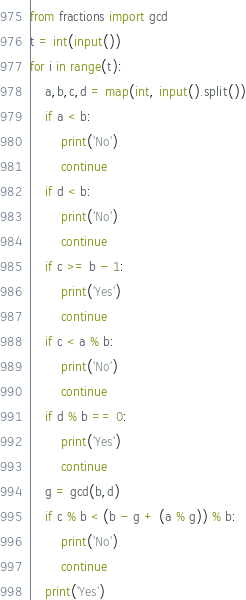<code> <loc_0><loc_0><loc_500><loc_500><_Python_>from fractions import gcd
t = int(input())
for i in range(t):
    a,b,c,d = map(int, input().split())
    if a < b:
        print('No')
        continue
    if d < b:
        print('No')
        continue
    if c >= b - 1:
        print('Yes')
        continue
    if c < a % b:
        print('No')
        continue
    if d % b == 0:
        print('Yes')
        continue
    g = gcd(b,d)
    if c % b < (b - g + (a % g)) % b:
        print('No')
        continue
    print('Yes')
</code> 